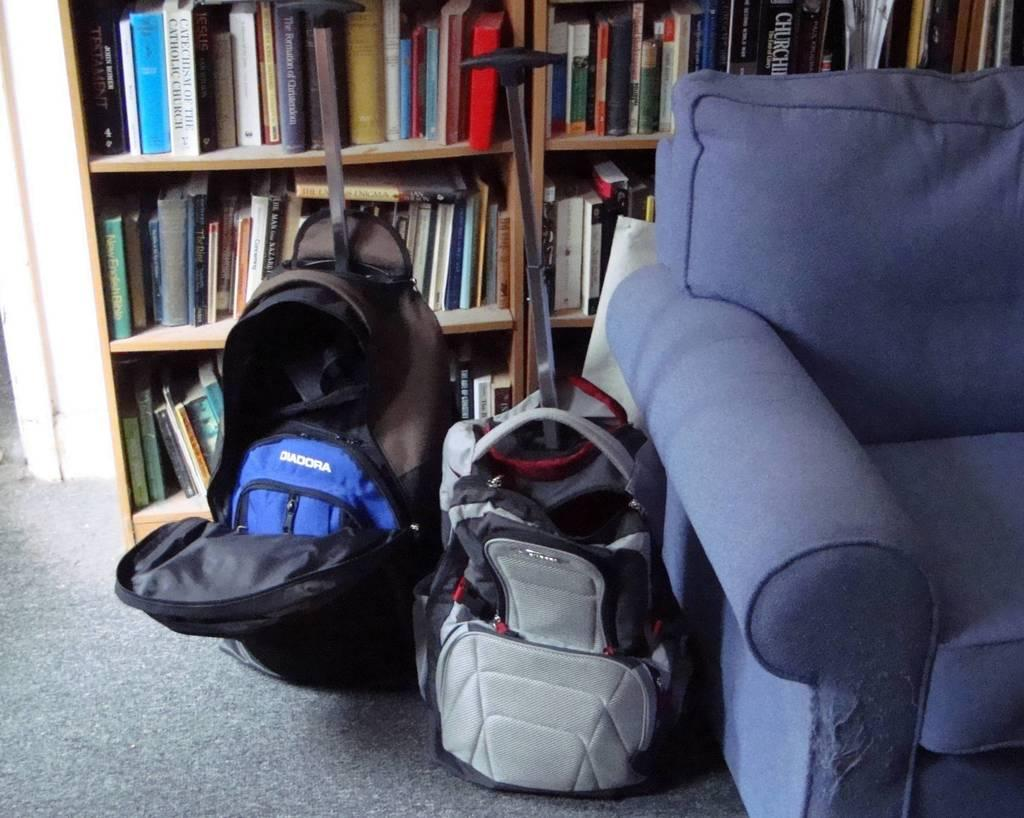What objects are located beside the sofa in the image? There are two bags beside the sofa in the image. What can be seen on the shelves behind the sofa? There are shelves with a large number of books behind the sofa. How many bells are hanging from the carriage in the image? There is no carriage or bells present in the image. What type of toothbrush is visible on the sofa in the image? There is no toothbrush visible on the sofa or anywhere else in the image. 